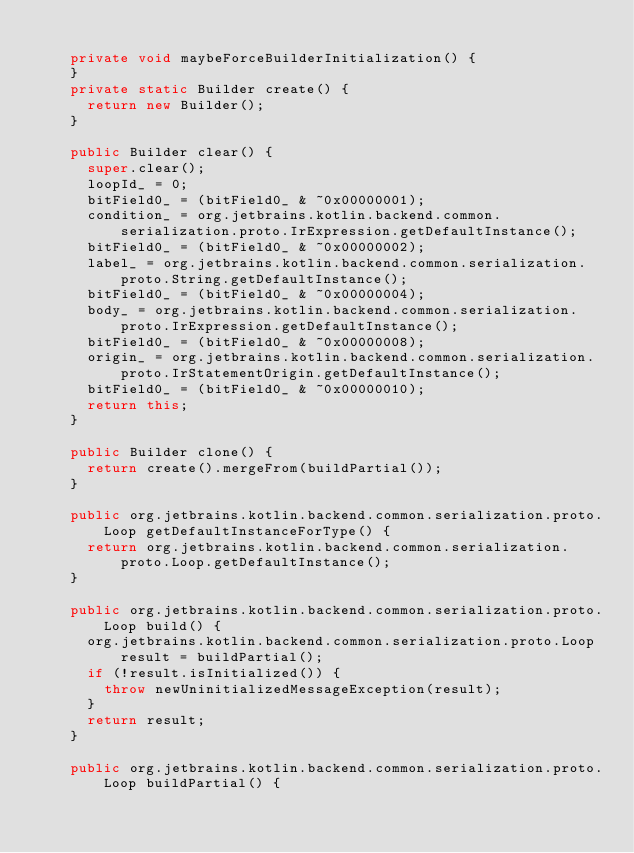Convert code to text. <code><loc_0><loc_0><loc_500><loc_500><_Java_>
    private void maybeForceBuilderInitialization() {
    }
    private static Builder create() {
      return new Builder();
    }

    public Builder clear() {
      super.clear();
      loopId_ = 0;
      bitField0_ = (bitField0_ & ~0x00000001);
      condition_ = org.jetbrains.kotlin.backend.common.serialization.proto.IrExpression.getDefaultInstance();
      bitField0_ = (bitField0_ & ~0x00000002);
      label_ = org.jetbrains.kotlin.backend.common.serialization.proto.String.getDefaultInstance();
      bitField0_ = (bitField0_ & ~0x00000004);
      body_ = org.jetbrains.kotlin.backend.common.serialization.proto.IrExpression.getDefaultInstance();
      bitField0_ = (bitField0_ & ~0x00000008);
      origin_ = org.jetbrains.kotlin.backend.common.serialization.proto.IrStatementOrigin.getDefaultInstance();
      bitField0_ = (bitField0_ & ~0x00000010);
      return this;
    }

    public Builder clone() {
      return create().mergeFrom(buildPartial());
    }

    public org.jetbrains.kotlin.backend.common.serialization.proto.Loop getDefaultInstanceForType() {
      return org.jetbrains.kotlin.backend.common.serialization.proto.Loop.getDefaultInstance();
    }

    public org.jetbrains.kotlin.backend.common.serialization.proto.Loop build() {
      org.jetbrains.kotlin.backend.common.serialization.proto.Loop result = buildPartial();
      if (!result.isInitialized()) {
        throw newUninitializedMessageException(result);
      }
      return result;
    }

    public org.jetbrains.kotlin.backend.common.serialization.proto.Loop buildPartial() {</code> 